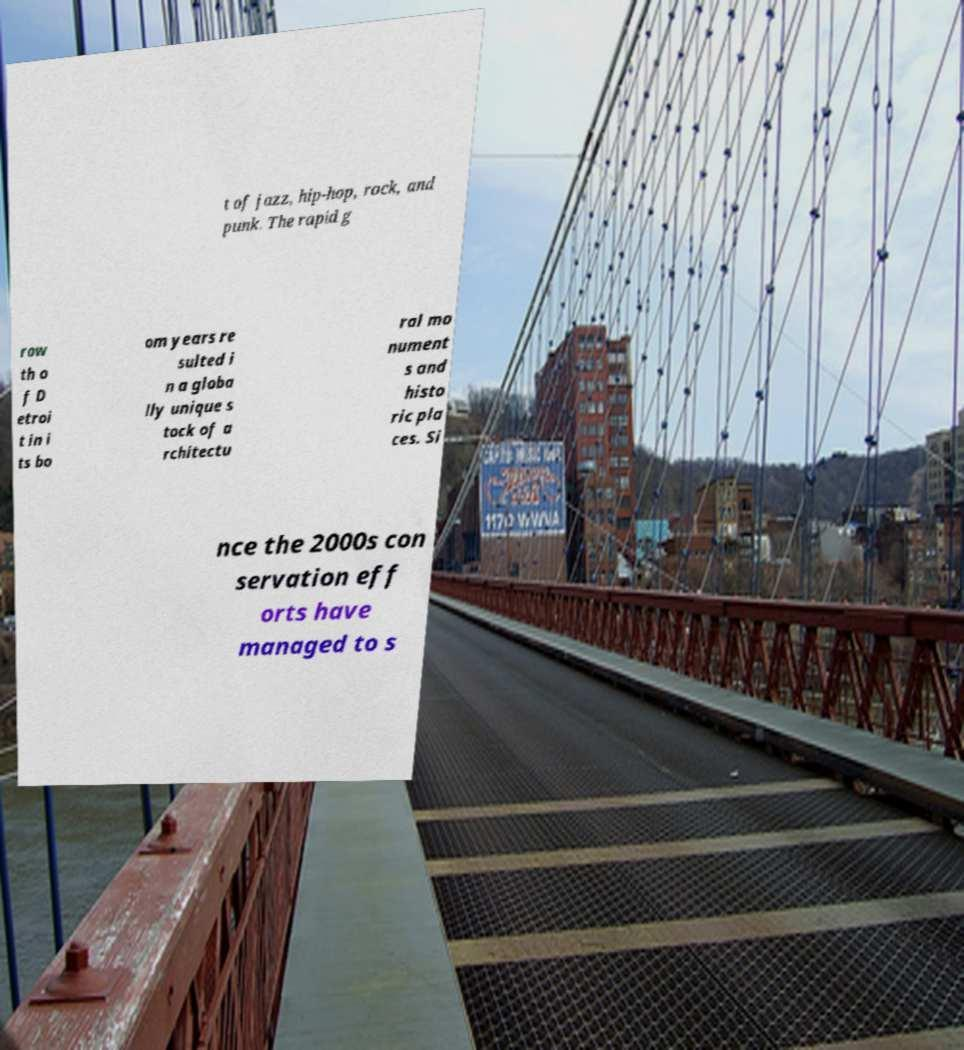Can you read and provide the text displayed in the image?This photo seems to have some interesting text. Can you extract and type it out for me? t of jazz, hip-hop, rock, and punk. The rapid g row th o f D etroi t in i ts bo om years re sulted i n a globa lly unique s tock of a rchitectu ral mo nument s and histo ric pla ces. Si nce the 2000s con servation eff orts have managed to s 